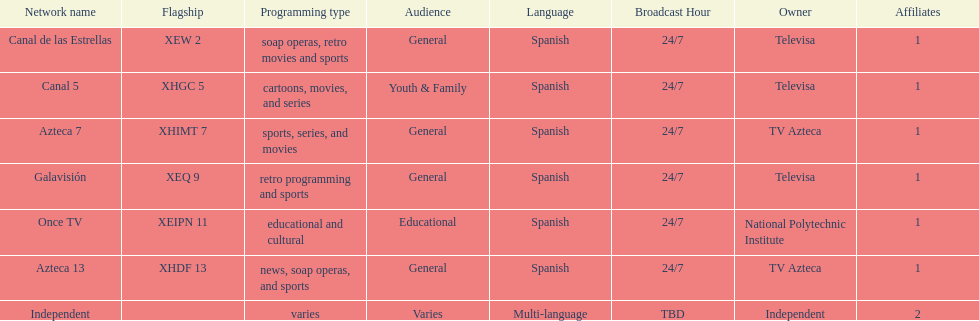How many networks do not air sports? 2. 